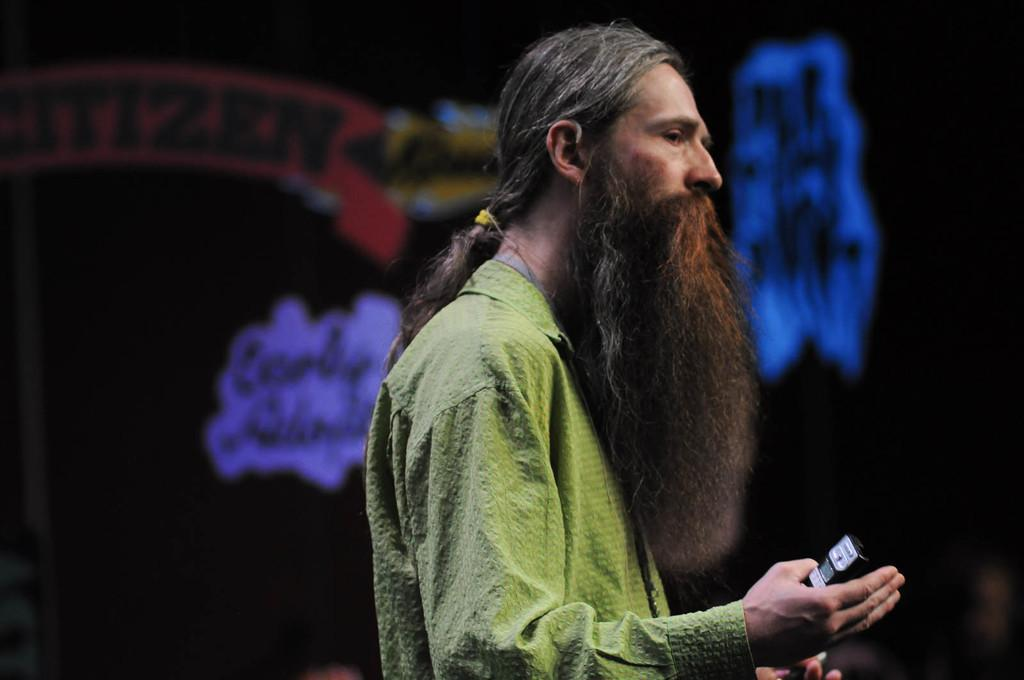What is the main subject of the image? There is a man standing in the center of the image. What is the man holding in his hand? The man is holding a black color object in his hand. What can be seen in the background of the image? There are posters in the background of the image. What is written on the posters? There is text written on the posters. How much honey is on the floor in the image? There is no honey present on the floor in the image. What type of story is being told through the posters in the image? The image does not provide enough information to determine the story being told through the posters. 